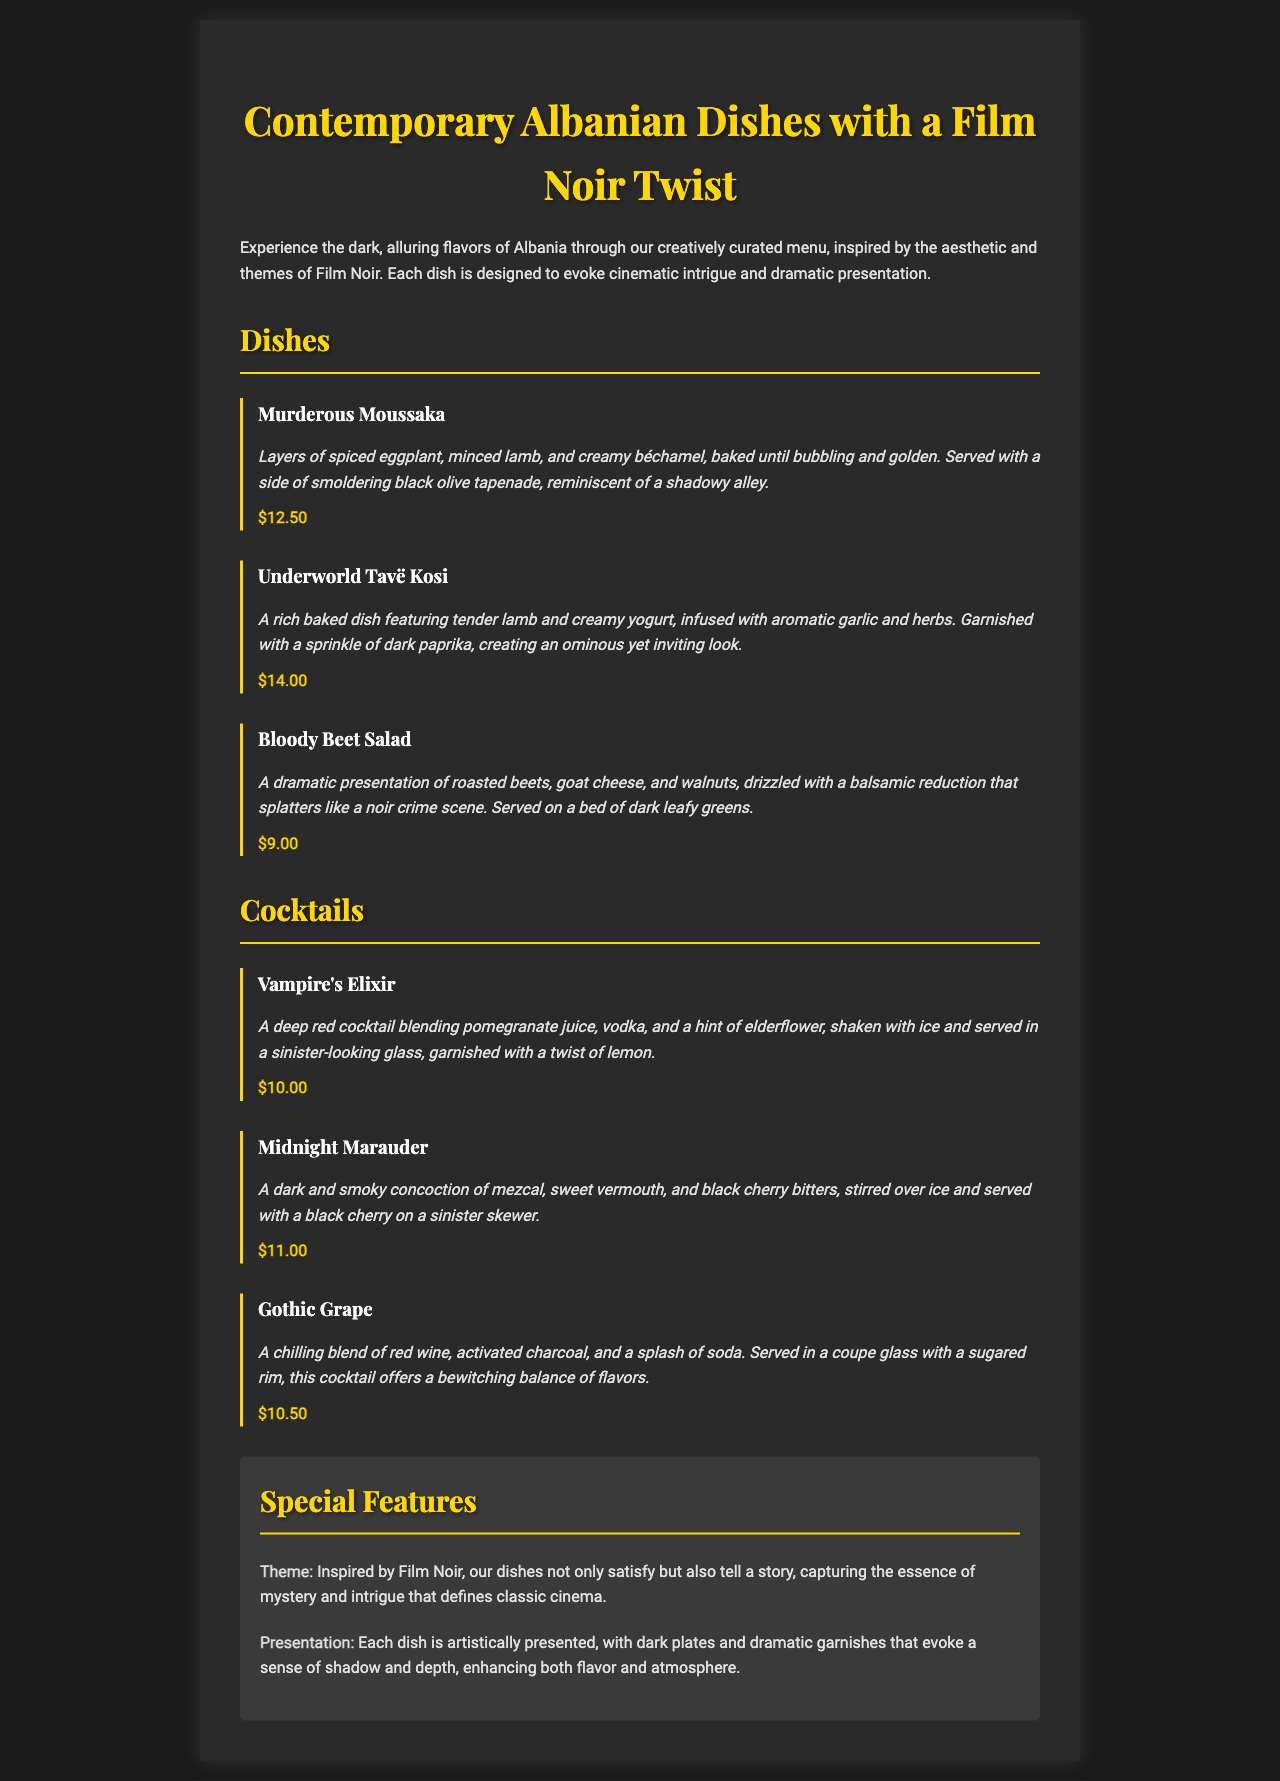what is the price of the Murderous Moussaka? The price is listed next to the dish, which is $12.50.
Answer: $12.50 what is the base ingredient of the Bloody Beet Salad? The salad features roasted beets as the primary component.
Answer: roasted beets which cocktail contains mezcal? The cocktail list includes the Midnight Marauder, which is made with mezcal.
Answer: Midnight Marauder what is the main theme of the dishes? The theme is inspired by Film Noir, suggesting a blend of mystery and intrigue.
Answer: Film Noir how many dishes are listed in the menu? Counting the entries in the Dishes section shows a total of three dishes offered.
Answer: three 